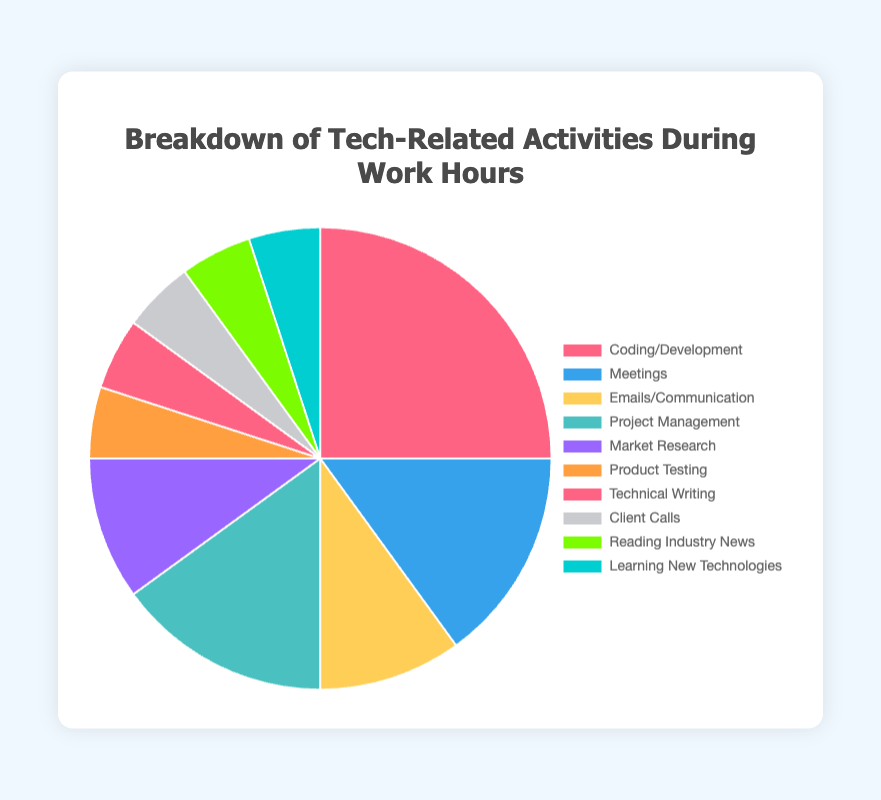What percentage of time is spent on Coding/Development? The figure shows a pie chart with different segments representing various activities. The Coding/Development segment is labeled with 25%.
Answer: 25% Which activity occupies the least amount of time individually? The pie chart shows each activity's percentage share of time spent. Several activities including Product Testing, Technical Writing, Client Calls, Reading Industry News, and Learning New Technologies each occupy 5%.
Answer: Product Testing, Technical Writing, Client Calls, Reading Industry News, Learning New Technologies Which activity takes more time, Meetings or Market Research? The pie chart labels show that Meetings take up 15%, while Market Research takes up 10%.
Answer: Meetings What is the total percentage of time spent on Project Management and Emails/Communication combined? The pie chart labels Project Management with 15% and Emails/Communication with 10%. The combined time is calculated by adding these two percentages. 15% + 10% = 25%
Answer: 25% What is the difference in time spent between Coding/Development and Technical Writing? Coding/Development takes up 25%, while Technical Writing takes 5%. Subtract 5% from 25% to find the difference. 25% - 5% = 20%
Answer: 20% Which activities together sum up to a total of 20%? The pie chart shows that each of Product Testing, Technical Writing, Client Calls, Reading Industry News, and Learning New Technologies takes up 5%. Two of these activities together make up 10%.
Answer: Two of Product Testing, Technical Writing, Client Calls, Reading Industry News, Learning New Technologies Are the time percentages spent on Meetings and Project Management equal? According to the pie chart, both Meetings and Project Management are labeled as taking up 15% of the time each.
Answer: Yes Considering only the time spent on Learning New Technologies and Reading Industry News, what proportion of the total work hours is this combined? Both activities are shown to take up 5% each in the pie chart. Combined, they account for 5% + 5% = 10% of the total work hours.
Answer: 10% Is more time spent on Product Testing or Client Calls? The pie chart indicates that both Product Testing and Client Calls occupy the same amount of time, which is 5% each.
Answer: Equal What's the combined percentage of time spent on activities other than Coding/Development and Meetings? Subtract the combined time of Coding/Development (25%) and Meetings (15%) from 100%. 100% - (25% + 15%) = 60%
Answer: 60% 